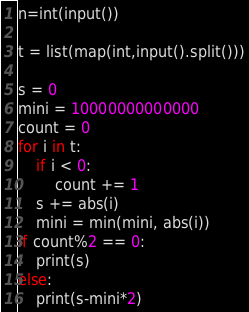Convert code to text. <code><loc_0><loc_0><loc_500><loc_500><_Python_>n=int(input())

t = list(map(int,input().split()))

s = 0
mini = 10000000000000
count = 0
for i in t:
    if i < 0:
        count += 1
    s += abs(i)
    mini = min(mini, abs(i))
if count%2 == 0:
    print(s)
else:
    print(s-mini*2)</code> 